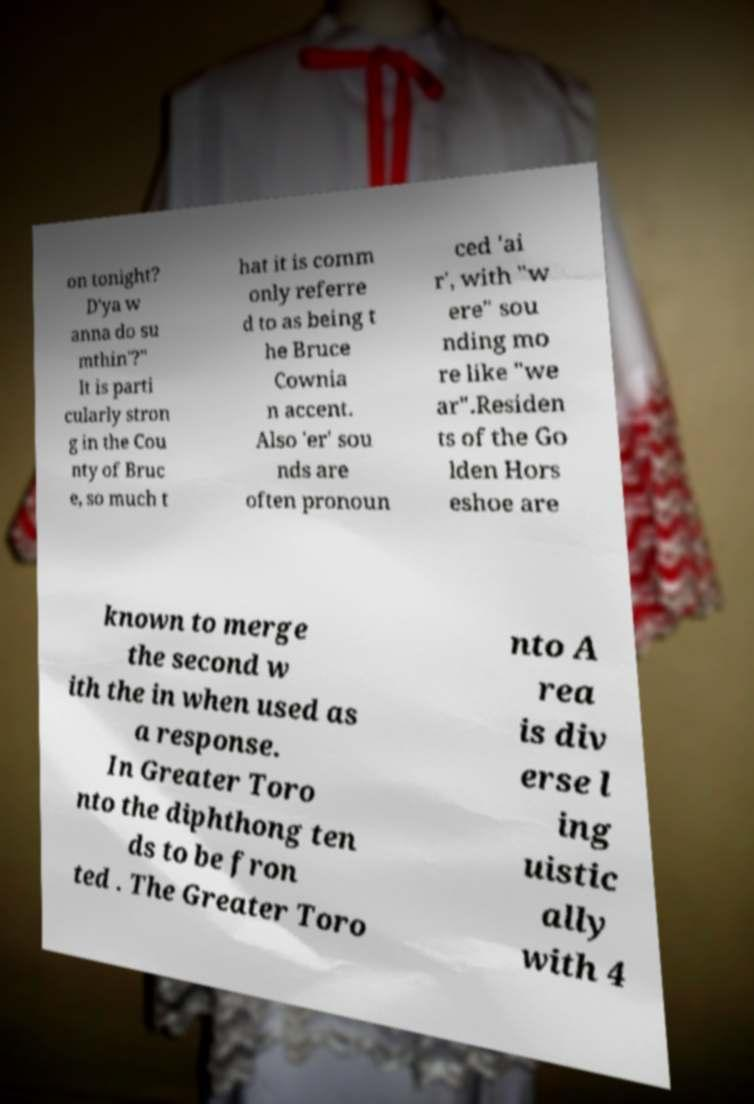There's text embedded in this image that I need extracted. Can you transcribe it verbatim? on tonight? D'ya w anna do su mthin'?" It is parti cularly stron g in the Cou nty of Bruc e, so much t hat it is comm only referre d to as being t he Bruce Cownia n accent. Also 'er' sou nds are often pronoun ced 'ai r', with "w ere" sou nding mo re like "we ar".Residen ts of the Go lden Hors eshoe are known to merge the second w ith the in when used as a response. In Greater Toro nto the diphthong ten ds to be fron ted . The Greater Toro nto A rea is div erse l ing uistic ally with 4 